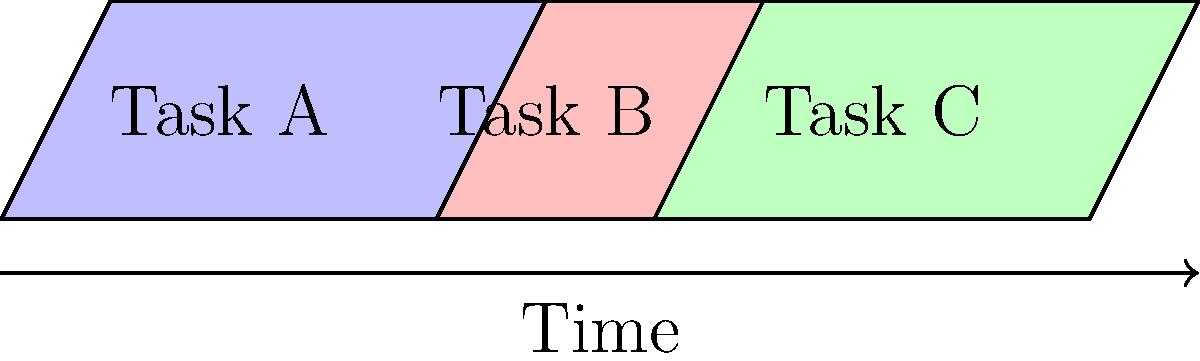In the project timeline represented by congruent parallelograms, Task B is dependent on Task A, and Task C is dependent on Task B. If Task A takes 4 days to complete, and the entire project (Tasks A, B, and C) must be completed in 11 days, how many days are allocated for Task C? To solve this problem, we'll follow these steps:

1. Recognize that the parallelograms are congruent, representing equal time allocation for each task.

2. Calculate the total number of parallelograms:
   There are 3 parallelograms, one for each task (A, B, and C).

3. Calculate the time represented by each parallelogram:
   Total project time = 11 days
   Number of parallelograms = 3
   Time per parallelogram = $\frac{11}{3}$ days

4. Round the time per parallelogram to the nearest whole number:
   $\frac{11}{3} \approx 3.67$ days, which rounds to 4 days

5. Verify that Task A indeed takes 4 days, as stated in the question.

6. Since all parallelograms are congruent, Task C will also take 4 days.

Therefore, 4 days are allocated for Task C.
Answer: 4 days 